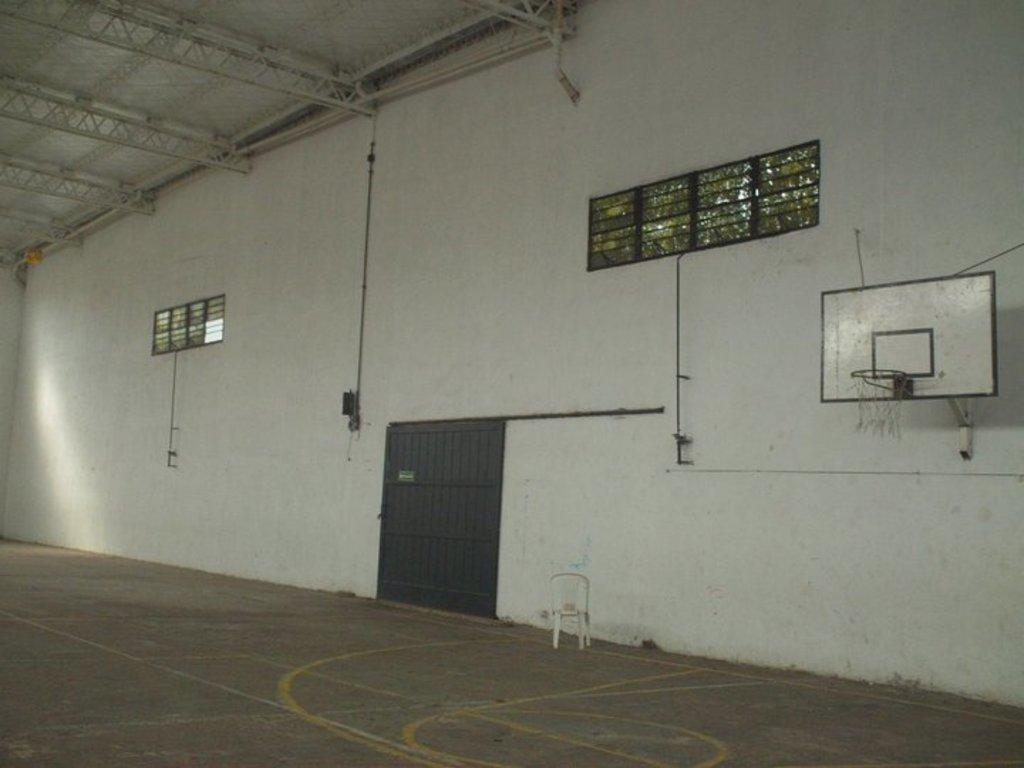What type of setting is shown in the image? The image depicts a court. What type of furniture is present in the image? There is a chair in the image. What architectural feature allows access to the court? There is a door in the image. What allows natural light into the court? There are windows in the image. What is the main feature of the game being played in the court? There is a hoop in the image. What can be seen in the background of the image? There is a wall in the background of the image. What is at the top of the image? There is a roof at the top of the image. What is at the bottom of the image? There is a floor at the bottom of the image. How many cherries are on the table in the image? There are no cherries present in the image. What type of woman is playing in the court in the image? There is no woman playing in the court in the image. 